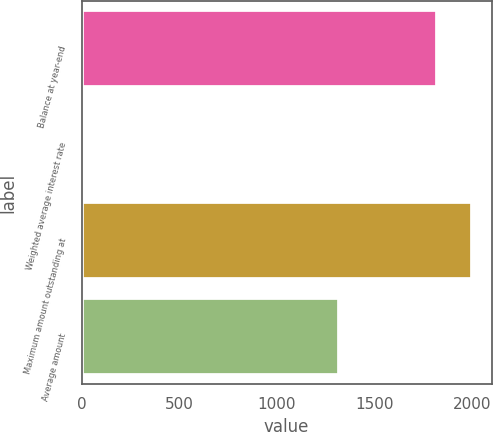Convert chart to OTSL. <chart><loc_0><loc_0><loc_500><loc_500><bar_chart><fcel>Balance at year-end<fcel>Weighted average interest rate<fcel>Maximum amount outstanding at<fcel>Average amount<nl><fcel>1820<fcel>2.41<fcel>2001.76<fcel>1319<nl></chart> 